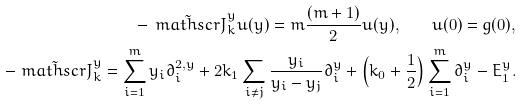Convert formula to latex. <formula><loc_0><loc_0><loc_500><loc_500>- \tilde { \ m a t h s c r { J } } _ { k } ^ { y } u ( y ) = m \frac { ( m + 1 ) } { 2 } u ( y ) , \quad u ( 0 ) = g ( 0 ) , \\ - \tilde { \ m a t h s c r { J } } _ { k } ^ { y } = \sum _ { i = 1 } ^ { m } y _ { i } \partial _ { i } ^ { 2 , y } + 2 k _ { 1 } \sum _ { i \neq j } \frac { y _ { i } } { y _ { i } - y _ { j } } \partial _ { i } ^ { y } + \left ( k _ { 0 } + \frac { 1 } { 2 } \right ) \sum _ { i = 1 } ^ { m } \partial _ { i } ^ { y } - E _ { 1 } ^ { y } .</formula> 